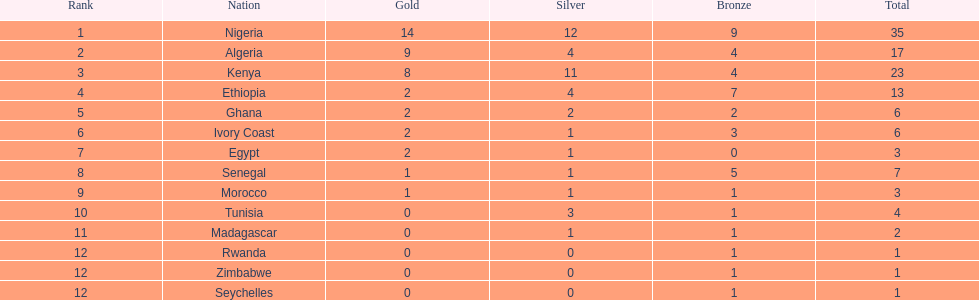What was the complete sum of medals the ivory coast received? 6. 